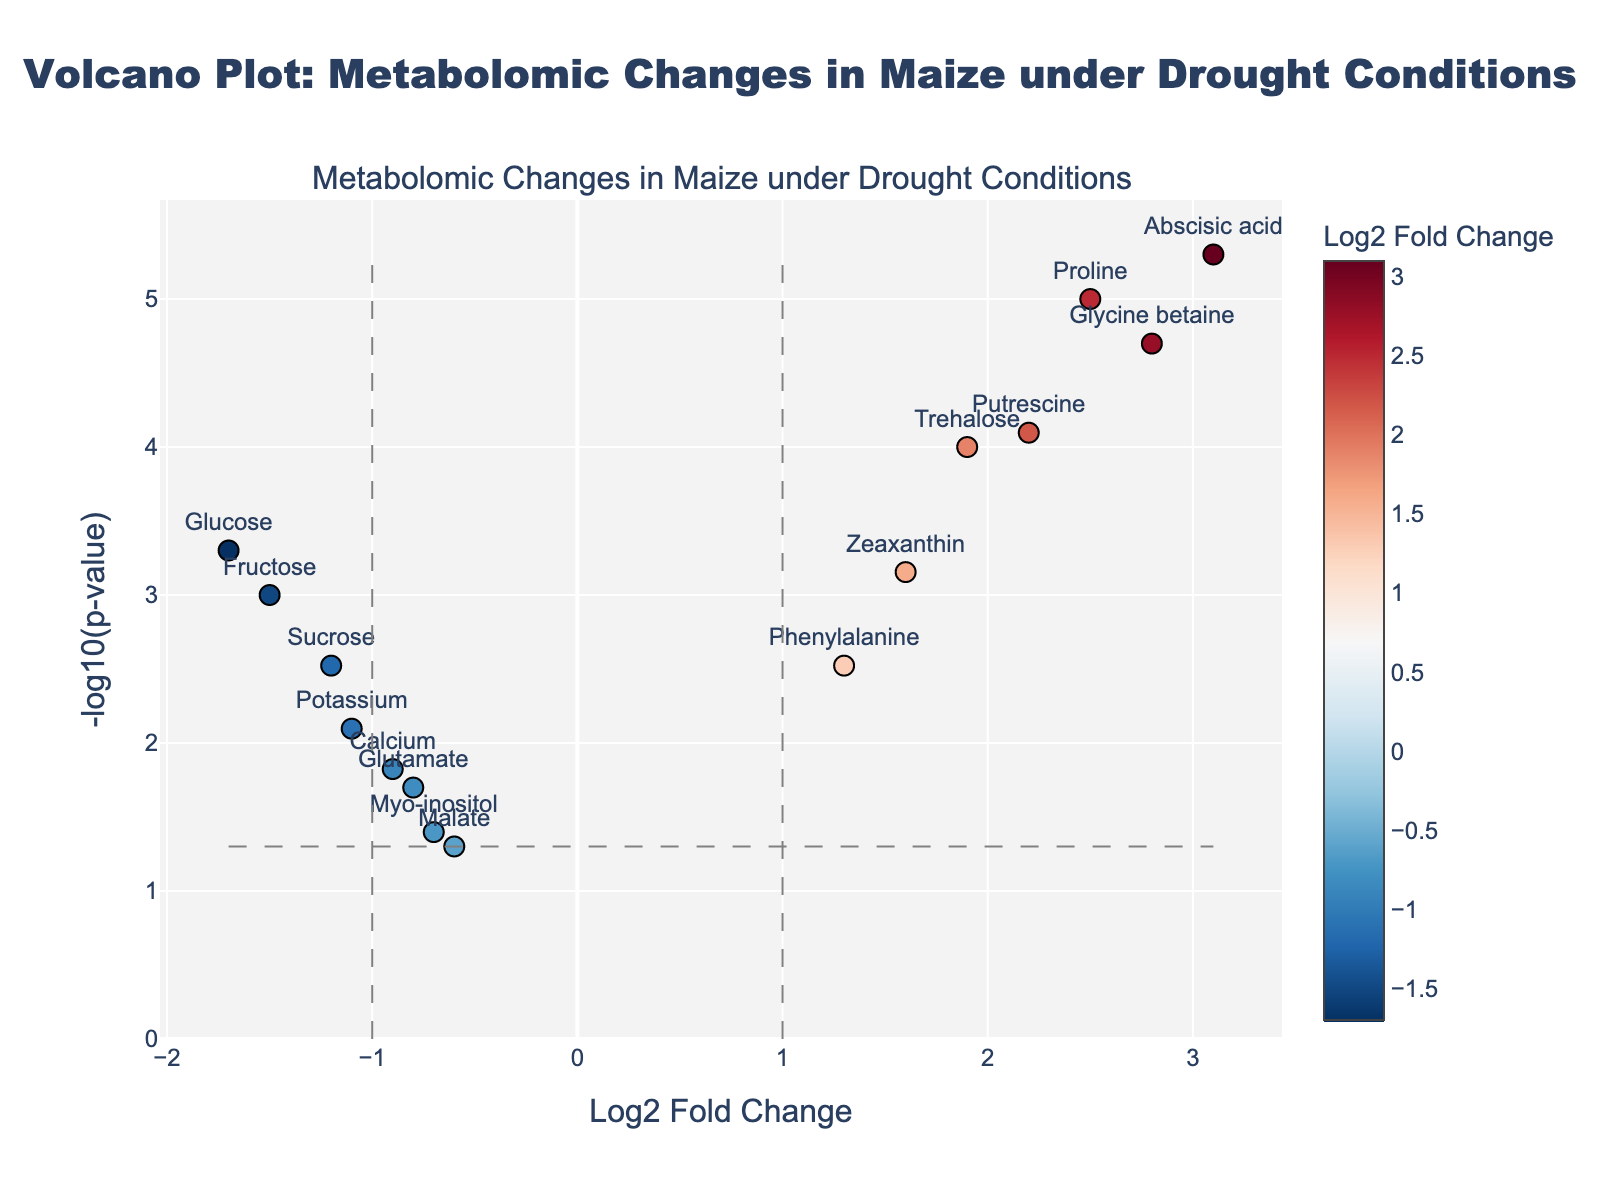Which metabolite has the highest -log10(p-value)? Look for the metabolite that is positioned at the highest point on the y-axis. The point representing Abscisic acid is at the highest position.
Answer: Abscisic acid How many metabolites have a log2 fold change greater than 1? Count the data points to the right of the vertical line at log2 fold change = 1. There are six metabolites: Proline, Glycine betaine, Trehalose, Phenylalanine, Putrescine, and Zeaxanthin.
Answer: 6 Which two metabolites show the most significant increase in log2 fold change? Identify the highest data points on the right (positive) side of the x-axis. Abscisic acid with log2FoldChange of 3.1 and Glycine betaine with log2FoldChange of 2.8 are the two highest points.
Answer: Abscisic acid and Glycine betaine What is the significance level indicated by the horizontal dash line? The horizontal dash line represents -log10(0.05) indicating the significance threshold. Calculate -log10(0.05), which equals approximately 1.3.
Answer: -log10(p-value) = 1.3 Which metabolites have both significant p-values (below 0.05) and increased fold change (greater than 1)? Find metabolites above the horizontal line y = 1.3 on the right of the vertical line x = 1. These metabolites are Proline, Glycine betaine, Trehalose, Phenylalanine, Putrescine, and Zeaxanthin.
Answer: Proline, Glycine betaine, Trehalose, Phenylalanine, Putrescine, Zeaxanthin What is the fold change and p-value for the metabolite Glucose? Locate the data point for Glucose and refer to its hover text. Glucose has a log2 fold change of -1.7 and a p-value of 0.0005.
Answer: log2 fold change: -1.7, p-value: 0.0005 How does the metabolite Sucrose compare to Fructose in terms of fold change and p-value? Compare the positions and hover text of Sucrose and Fructose. Sucrose has a log2 fold change of -1.2 and a p-value of 0.003, while Fructose has a log2 fold change of -1.5 and a p-value of 0.001.
Answer: Sucrose: log2 fold change: -1.2, p-value: 0.003; Fructose: log2 fold change: -1.5, p-value: 0.001 What can you infer about the metabolite Proline's change and significance under drought conditions? Refer to the position of Proline on the plot. Proline has a log2 fold change of 2.5, indicating a significant increase, and a p-value of 0.00001, indicating strong significance.
Answer: Significant increase, highly significant Are there any metabolites that show a log2 fold change less than -1 but with non-significant p-values? Look at the points to the left of the vertical line at log2 fold change = -1 and below the horizontal line at p-value threshold. Potassium and Myo-inositol have log2 fold changes of -1.1 and -0.7, respectively, but Myo-inositol has a non-significant p-value.
Answer: Myo-inositol 